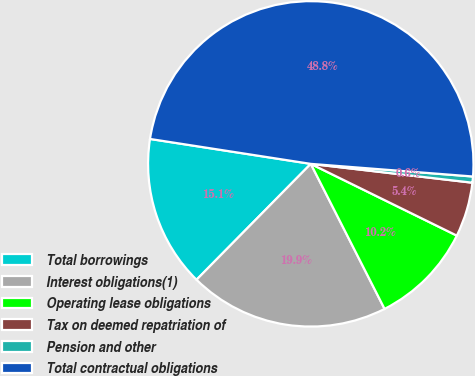<chart> <loc_0><loc_0><loc_500><loc_500><pie_chart><fcel>Total borrowings<fcel>Interest obligations(1)<fcel>Operating lease obligations<fcel>Tax on deemed repatriation of<fcel>Pension and other<fcel>Total contractual obligations<nl><fcel>15.06%<fcel>19.88%<fcel>10.24%<fcel>5.42%<fcel>0.61%<fcel>48.79%<nl></chart> 